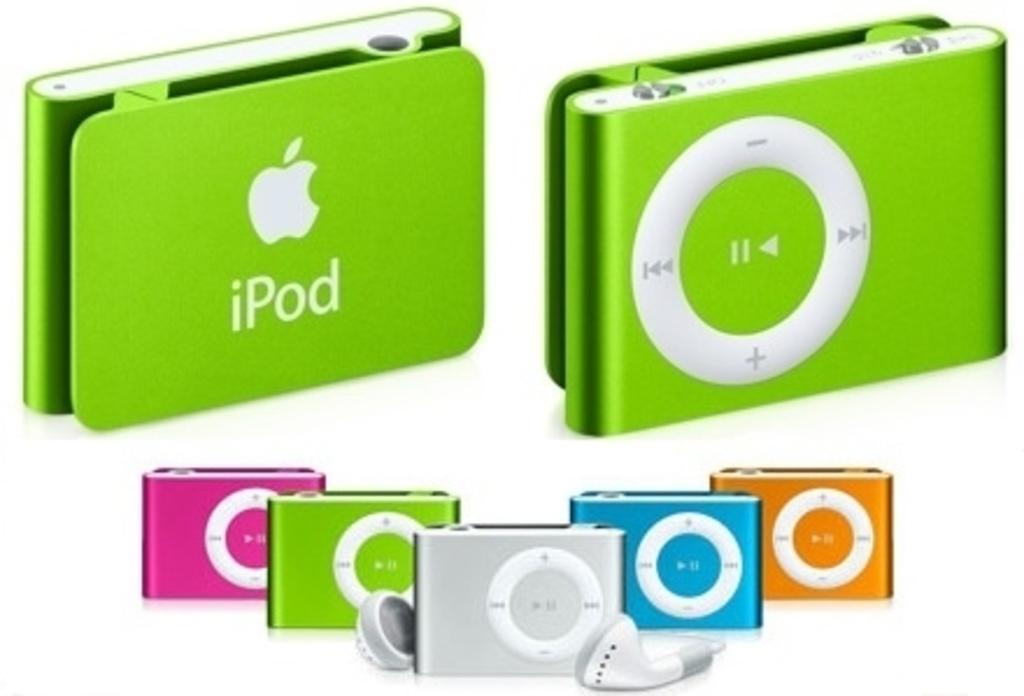Can you describe this image briefly? In this image we can see rectangular shaped headphones which are in green, pink and blue color. 